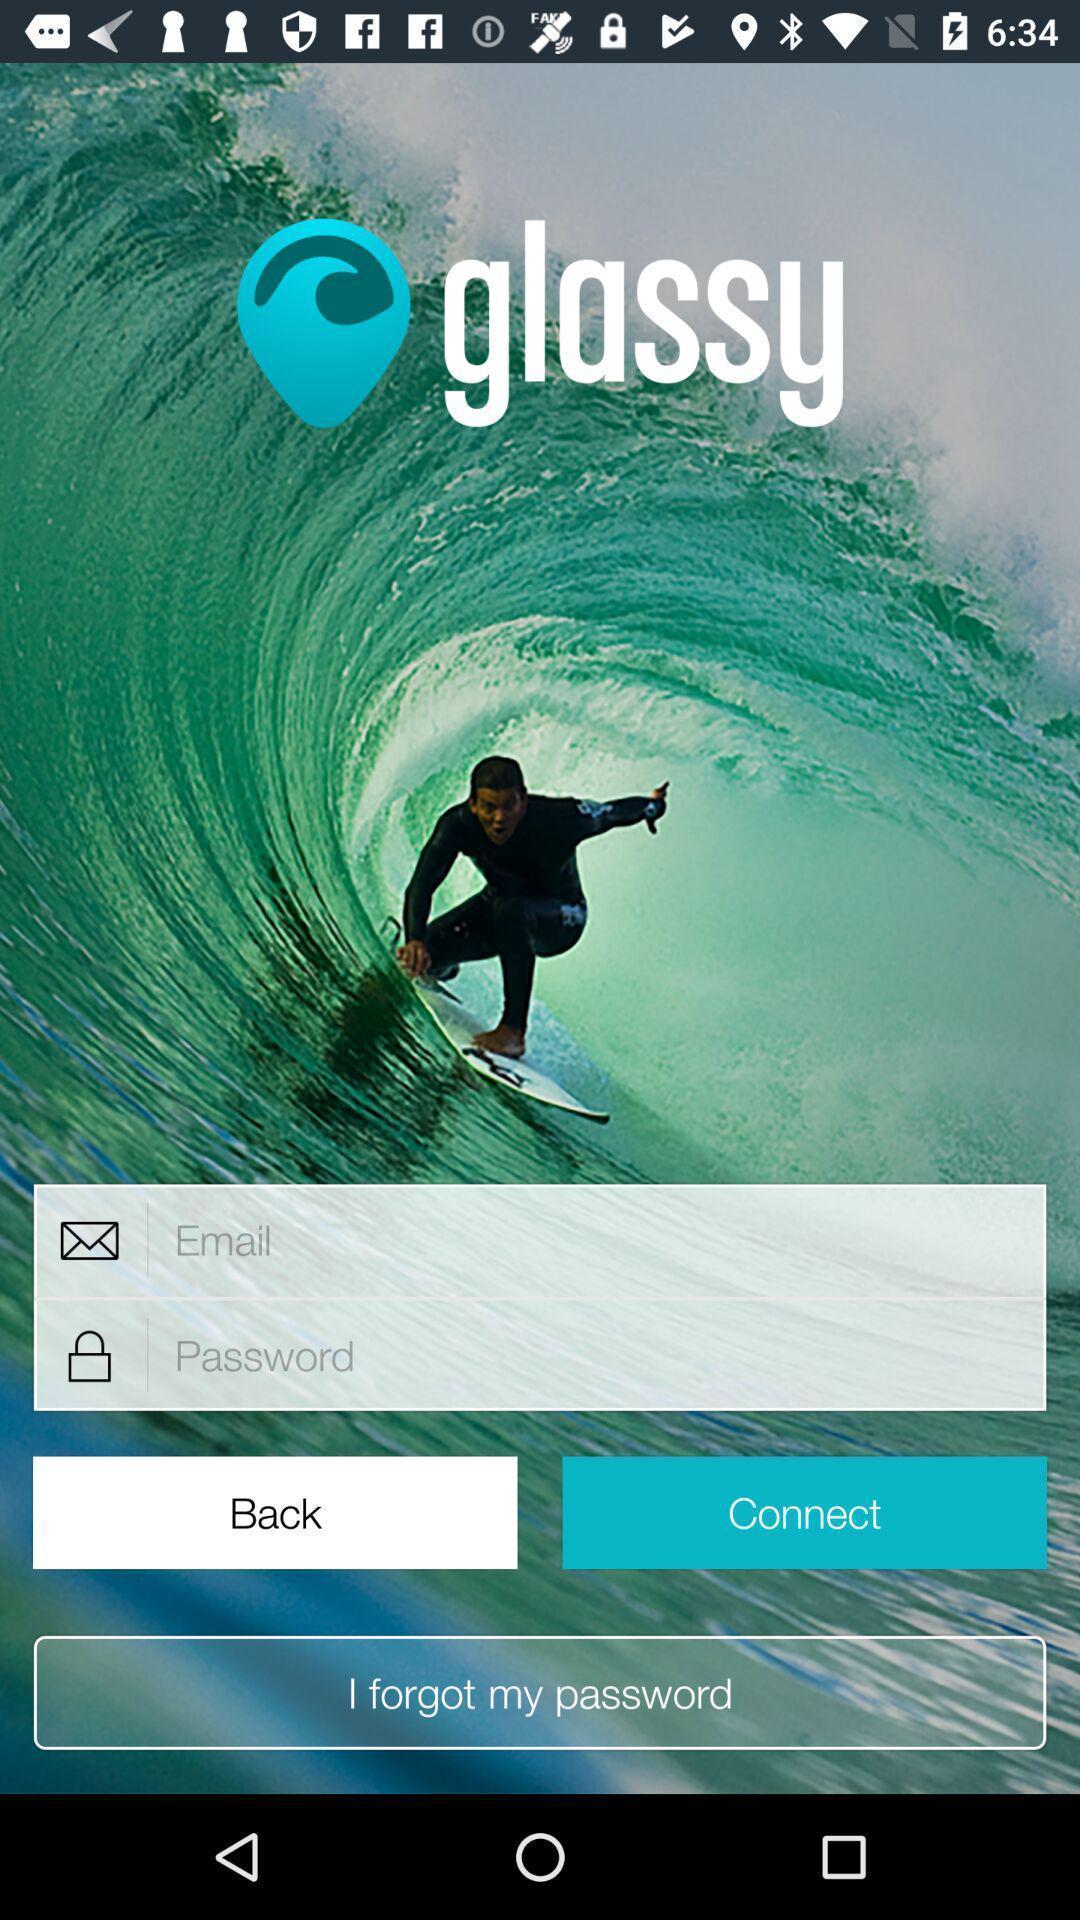Please provide a description for this image. Sign in page. 